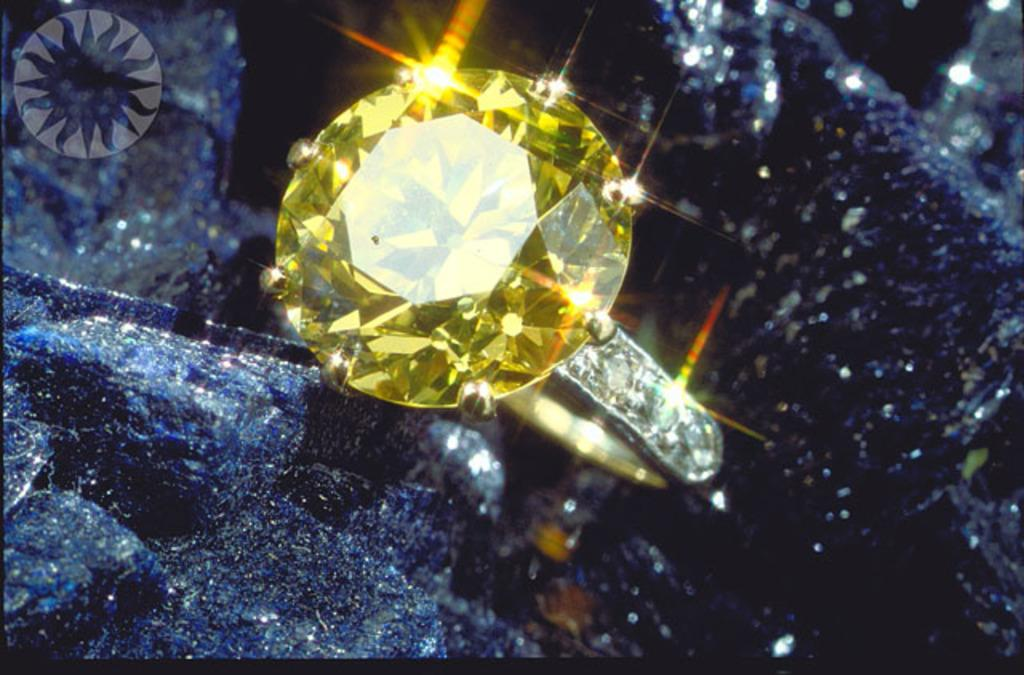What is the main object in the image? There is a diamond ring in the image. Where is the diamond ring placed? The diamond ring is on a cloth. What is the color of the diamond in the ring? The diamond is yellow in color. Are there any tomatoes or lettuce visible in the image? No, there are no tomatoes or lettuce present in the image. Is there a cable attached to the diamond ring in the image? No, there is no cable attached to the diamond ring in the image. 